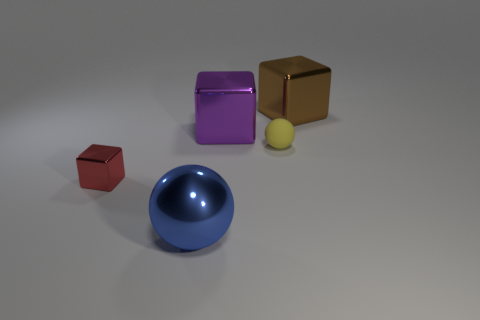What might be the purpose of arranging these objects in this manner? The arrangement of these objects might serve various purposes, such as being part of a visual composition study, which examines the interplay of light, shadow, and reflections on different geometrical shapes. Alternatively, it could be a setup for a computer graphics rendering test, used to demonstrate material properties and the effects of a virtual lighting environment on different surfaces. 